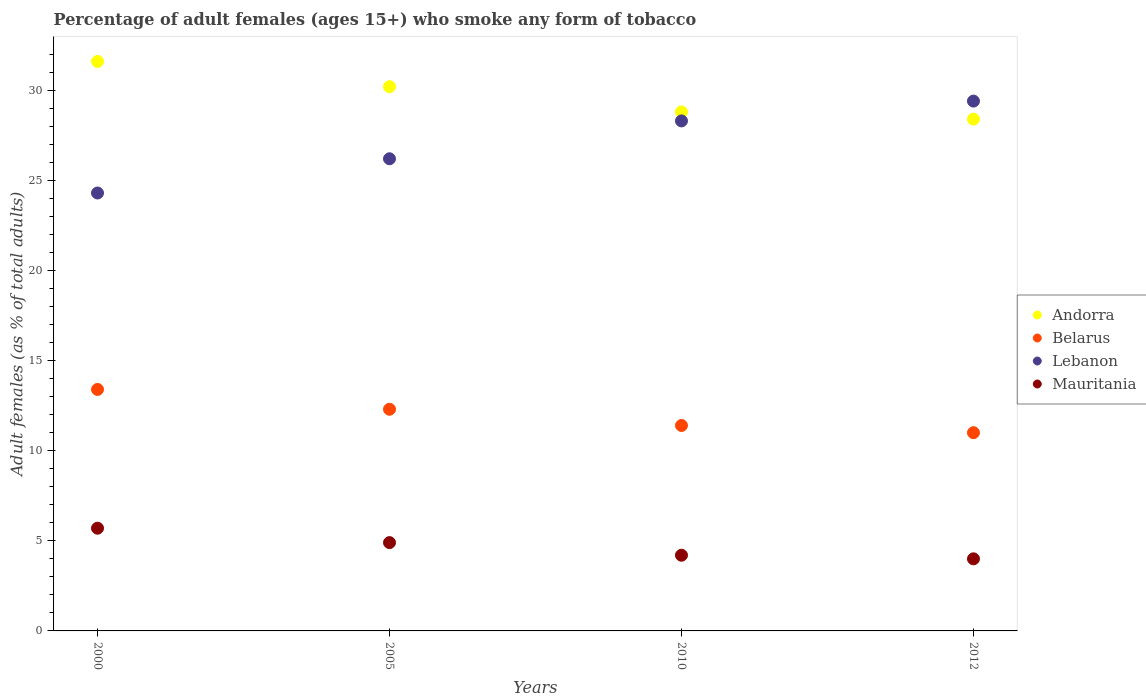How many different coloured dotlines are there?
Offer a terse response. 4. Is the number of dotlines equal to the number of legend labels?
Provide a succinct answer. Yes. What is the percentage of adult females who smoke in Mauritania in 2012?
Keep it short and to the point. 4. Across all years, what is the minimum percentage of adult females who smoke in Lebanon?
Your answer should be very brief. 24.3. What is the total percentage of adult females who smoke in Andorra in the graph?
Provide a short and direct response. 119. What is the average percentage of adult females who smoke in Lebanon per year?
Provide a short and direct response. 27.05. In the year 2012, what is the difference between the percentage of adult females who smoke in Mauritania and percentage of adult females who smoke in Andorra?
Your answer should be compact. -24.4. In how many years, is the percentage of adult females who smoke in Mauritania greater than 30 %?
Provide a succinct answer. 0. What is the ratio of the percentage of adult females who smoke in Andorra in 2000 to that in 2005?
Provide a succinct answer. 1.05. Is the percentage of adult females who smoke in Mauritania in 2000 less than that in 2005?
Your answer should be very brief. No. What is the difference between the highest and the second highest percentage of adult females who smoke in Belarus?
Offer a terse response. 1.1. What is the difference between the highest and the lowest percentage of adult females who smoke in Andorra?
Offer a very short reply. 3.2. Is the sum of the percentage of adult females who smoke in Lebanon in 2000 and 2012 greater than the maximum percentage of adult females who smoke in Andorra across all years?
Provide a short and direct response. Yes. Is the percentage of adult females who smoke in Andorra strictly greater than the percentage of adult females who smoke in Belarus over the years?
Your response must be concise. Yes. Is the percentage of adult females who smoke in Mauritania strictly less than the percentage of adult females who smoke in Belarus over the years?
Your response must be concise. Yes. How many dotlines are there?
Offer a very short reply. 4. How many years are there in the graph?
Offer a very short reply. 4. Are the values on the major ticks of Y-axis written in scientific E-notation?
Make the answer very short. No. Does the graph contain any zero values?
Provide a short and direct response. No. Does the graph contain grids?
Provide a short and direct response. No. How many legend labels are there?
Your answer should be compact. 4. What is the title of the graph?
Keep it short and to the point. Percentage of adult females (ages 15+) who smoke any form of tobacco. Does "St. Kitts and Nevis" appear as one of the legend labels in the graph?
Ensure brevity in your answer.  No. What is the label or title of the X-axis?
Keep it short and to the point. Years. What is the label or title of the Y-axis?
Keep it short and to the point. Adult females (as % of total adults). What is the Adult females (as % of total adults) in Andorra in 2000?
Provide a short and direct response. 31.6. What is the Adult females (as % of total adults) of Belarus in 2000?
Provide a succinct answer. 13.4. What is the Adult females (as % of total adults) of Lebanon in 2000?
Your answer should be very brief. 24.3. What is the Adult females (as % of total adults) in Mauritania in 2000?
Ensure brevity in your answer.  5.7. What is the Adult females (as % of total adults) in Andorra in 2005?
Make the answer very short. 30.2. What is the Adult females (as % of total adults) of Lebanon in 2005?
Provide a short and direct response. 26.2. What is the Adult females (as % of total adults) of Andorra in 2010?
Your response must be concise. 28.8. What is the Adult females (as % of total adults) of Belarus in 2010?
Your answer should be very brief. 11.4. What is the Adult females (as % of total adults) in Lebanon in 2010?
Provide a succinct answer. 28.3. What is the Adult females (as % of total adults) in Andorra in 2012?
Your answer should be compact. 28.4. What is the Adult females (as % of total adults) in Belarus in 2012?
Give a very brief answer. 11. What is the Adult females (as % of total adults) of Lebanon in 2012?
Make the answer very short. 29.4. Across all years, what is the maximum Adult females (as % of total adults) of Andorra?
Your answer should be compact. 31.6. Across all years, what is the maximum Adult females (as % of total adults) of Belarus?
Make the answer very short. 13.4. Across all years, what is the maximum Adult females (as % of total adults) in Lebanon?
Offer a terse response. 29.4. Across all years, what is the maximum Adult females (as % of total adults) in Mauritania?
Make the answer very short. 5.7. Across all years, what is the minimum Adult females (as % of total adults) of Andorra?
Your answer should be very brief. 28.4. Across all years, what is the minimum Adult females (as % of total adults) of Belarus?
Offer a very short reply. 11. Across all years, what is the minimum Adult females (as % of total adults) in Lebanon?
Your answer should be compact. 24.3. What is the total Adult females (as % of total adults) of Andorra in the graph?
Your answer should be very brief. 119. What is the total Adult females (as % of total adults) in Belarus in the graph?
Your answer should be compact. 48.1. What is the total Adult females (as % of total adults) of Lebanon in the graph?
Your response must be concise. 108.2. What is the difference between the Adult females (as % of total adults) of Mauritania in 2000 and that in 2005?
Ensure brevity in your answer.  0.8. What is the difference between the Adult females (as % of total adults) in Andorra in 2000 and that in 2012?
Provide a succinct answer. 3.2. What is the difference between the Adult females (as % of total adults) of Lebanon in 2000 and that in 2012?
Offer a terse response. -5.1. What is the difference between the Adult females (as % of total adults) in Mauritania in 2005 and that in 2010?
Offer a very short reply. 0.7. What is the difference between the Adult females (as % of total adults) of Andorra in 2005 and that in 2012?
Your response must be concise. 1.8. What is the difference between the Adult females (as % of total adults) in Mauritania in 2005 and that in 2012?
Provide a short and direct response. 0.9. What is the difference between the Adult females (as % of total adults) of Mauritania in 2010 and that in 2012?
Provide a short and direct response. 0.2. What is the difference between the Adult females (as % of total adults) of Andorra in 2000 and the Adult females (as % of total adults) of Belarus in 2005?
Keep it short and to the point. 19.3. What is the difference between the Adult females (as % of total adults) in Andorra in 2000 and the Adult females (as % of total adults) in Mauritania in 2005?
Your answer should be compact. 26.7. What is the difference between the Adult females (as % of total adults) of Lebanon in 2000 and the Adult females (as % of total adults) of Mauritania in 2005?
Offer a terse response. 19.4. What is the difference between the Adult females (as % of total adults) in Andorra in 2000 and the Adult females (as % of total adults) in Belarus in 2010?
Give a very brief answer. 20.2. What is the difference between the Adult females (as % of total adults) in Andorra in 2000 and the Adult females (as % of total adults) in Mauritania in 2010?
Your answer should be compact. 27.4. What is the difference between the Adult females (as % of total adults) of Belarus in 2000 and the Adult females (as % of total adults) of Lebanon in 2010?
Provide a succinct answer. -14.9. What is the difference between the Adult females (as % of total adults) in Lebanon in 2000 and the Adult females (as % of total adults) in Mauritania in 2010?
Ensure brevity in your answer.  20.1. What is the difference between the Adult females (as % of total adults) of Andorra in 2000 and the Adult females (as % of total adults) of Belarus in 2012?
Make the answer very short. 20.6. What is the difference between the Adult females (as % of total adults) in Andorra in 2000 and the Adult females (as % of total adults) in Lebanon in 2012?
Keep it short and to the point. 2.2. What is the difference between the Adult females (as % of total adults) of Andorra in 2000 and the Adult females (as % of total adults) of Mauritania in 2012?
Provide a succinct answer. 27.6. What is the difference between the Adult females (as % of total adults) of Belarus in 2000 and the Adult females (as % of total adults) of Lebanon in 2012?
Your response must be concise. -16. What is the difference between the Adult females (as % of total adults) in Belarus in 2000 and the Adult females (as % of total adults) in Mauritania in 2012?
Ensure brevity in your answer.  9.4. What is the difference between the Adult females (as % of total adults) of Lebanon in 2000 and the Adult females (as % of total adults) of Mauritania in 2012?
Make the answer very short. 20.3. What is the difference between the Adult females (as % of total adults) in Andorra in 2005 and the Adult females (as % of total adults) in Belarus in 2010?
Give a very brief answer. 18.8. What is the difference between the Adult females (as % of total adults) of Andorra in 2005 and the Adult females (as % of total adults) of Mauritania in 2010?
Give a very brief answer. 26. What is the difference between the Adult females (as % of total adults) of Lebanon in 2005 and the Adult females (as % of total adults) of Mauritania in 2010?
Keep it short and to the point. 22. What is the difference between the Adult females (as % of total adults) of Andorra in 2005 and the Adult females (as % of total adults) of Belarus in 2012?
Provide a short and direct response. 19.2. What is the difference between the Adult females (as % of total adults) of Andorra in 2005 and the Adult females (as % of total adults) of Lebanon in 2012?
Provide a short and direct response. 0.8. What is the difference between the Adult females (as % of total adults) in Andorra in 2005 and the Adult females (as % of total adults) in Mauritania in 2012?
Your response must be concise. 26.2. What is the difference between the Adult females (as % of total adults) of Belarus in 2005 and the Adult females (as % of total adults) of Lebanon in 2012?
Provide a short and direct response. -17.1. What is the difference between the Adult females (as % of total adults) of Belarus in 2005 and the Adult females (as % of total adults) of Mauritania in 2012?
Your answer should be compact. 8.3. What is the difference between the Adult females (as % of total adults) in Andorra in 2010 and the Adult females (as % of total adults) in Belarus in 2012?
Make the answer very short. 17.8. What is the difference between the Adult females (as % of total adults) in Andorra in 2010 and the Adult females (as % of total adults) in Lebanon in 2012?
Ensure brevity in your answer.  -0.6. What is the difference between the Adult females (as % of total adults) of Andorra in 2010 and the Adult females (as % of total adults) of Mauritania in 2012?
Your answer should be compact. 24.8. What is the difference between the Adult females (as % of total adults) of Belarus in 2010 and the Adult females (as % of total adults) of Lebanon in 2012?
Give a very brief answer. -18. What is the difference between the Adult females (as % of total adults) in Lebanon in 2010 and the Adult females (as % of total adults) in Mauritania in 2012?
Your answer should be compact. 24.3. What is the average Adult females (as % of total adults) in Andorra per year?
Ensure brevity in your answer.  29.75. What is the average Adult females (as % of total adults) in Belarus per year?
Keep it short and to the point. 12.03. What is the average Adult females (as % of total adults) in Lebanon per year?
Make the answer very short. 27.05. What is the average Adult females (as % of total adults) in Mauritania per year?
Offer a terse response. 4.7. In the year 2000, what is the difference between the Adult females (as % of total adults) in Andorra and Adult females (as % of total adults) in Lebanon?
Ensure brevity in your answer.  7.3. In the year 2000, what is the difference between the Adult females (as % of total adults) of Andorra and Adult females (as % of total adults) of Mauritania?
Offer a terse response. 25.9. In the year 2000, what is the difference between the Adult females (as % of total adults) in Belarus and Adult females (as % of total adults) in Lebanon?
Provide a short and direct response. -10.9. In the year 2000, what is the difference between the Adult females (as % of total adults) of Belarus and Adult females (as % of total adults) of Mauritania?
Keep it short and to the point. 7.7. In the year 2000, what is the difference between the Adult females (as % of total adults) in Lebanon and Adult females (as % of total adults) in Mauritania?
Give a very brief answer. 18.6. In the year 2005, what is the difference between the Adult females (as % of total adults) of Andorra and Adult females (as % of total adults) of Lebanon?
Provide a short and direct response. 4. In the year 2005, what is the difference between the Adult females (as % of total adults) in Andorra and Adult females (as % of total adults) in Mauritania?
Offer a terse response. 25.3. In the year 2005, what is the difference between the Adult females (as % of total adults) in Belarus and Adult females (as % of total adults) in Lebanon?
Make the answer very short. -13.9. In the year 2005, what is the difference between the Adult females (as % of total adults) of Belarus and Adult females (as % of total adults) of Mauritania?
Ensure brevity in your answer.  7.4. In the year 2005, what is the difference between the Adult females (as % of total adults) of Lebanon and Adult females (as % of total adults) of Mauritania?
Offer a very short reply. 21.3. In the year 2010, what is the difference between the Adult females (as % of total adults) of Andorra and Adult females (as % of total adults) of Mauritania?
Ensure brevity in your answer.  24.6. In the year 2010, what is the difference between the Adult females (as % of total adults) in Belarus and Adult females (as % of total adults) in Lebanon?
Provide a succinct answer. -16.9. In the year 2010, what is the difference between the Adult females (as % of total adults) in Belarus and Adult females (as % of total adults) in Mauritania?
Provide a short and direct response. 7.2. In the year 2010, what is the difference between the Adult females (as % of total adults) in Lebanon and Adult females (as % of total adults) in Mauritania?
Give a very brief answer. 24.1. In the year 2012, what is the difference between the Adult females (as % of total adults) in Andorra and Adult females (as % of total adults) in Belarus?
Give a very brief answer. 17.4. In the year 2012, what is the difference between the Adult females (as % of total adults) in Andorra and Adult females (as % of total adults) in Mauritania?
Your response must be concise. 24.4. In the year 2012, what is the difference between the Adult females (as % of total adults) of Belarus and Adult females (as % of total adults) of Lebanon?
Make the answer very short. -18.4. In the year 2012, what is the difference between the Adult females (as % of total adults) of Lebanon and Adult females (as % of total adults) of Mauritania?
Give a very brief answer. 25.4. What is the ratio of the Adult females (as % of total adults) of Andorra in 2000 to that in 2005?
Your response must be concise. 1.05. What is the ratio of the Adult females (as % of total adults) of Belarus in 2000 to that in 2005?
Your answer should be compact. 1.09. What is the ratio of the Adult females (as % of total adults) in Lebanon in 2000 to that in 2005?
Give a very brief answer. 0.93. What is the ratio of the Adult females (as % of total adults) in Mauritania in 2000 to that in 2005?
Offer a terse response. 1.16. What is the ratio of the Adult females (as % of total adults) of Andorra in 2000 to that in 2010?
Make the answer very short. 1.1. What is the ratio of the Adult females (as % of total adults) in Belarus in 2000 to that in 2010?
Keep it short and to the point. 1.18. What is the ratio of the Adult females (as % of total adults) of Lebanon in 2000 to that in 2010?
Make the answer very short. 0.86. What is the ratio of the Adult females (as % of total adults) of Mauritania in 2000 to that in 2010?
Your answer should be very brief. 1.36. What is the ratio of the Adult females (as % of total adults) of Andorra in 2000 to that in 2012?
Make the answer very short. 1.11. What is the ratio of the Adult females (as % of total adults) of Belarus in 2000 to that in 2012?
Your response must be concise. 1.22. What is the ratio of the Adult females (as % of total adults) in Lebanon in 2000 to that in 2012?
Offer a very short reply. 0.83. What is the ratio of the Adult females (as % of total adults) of Mauritania in 2000 to that in 2012?
Your answer should be compact. 1.43. What is the ratio of the Adult females (as % of total adults) of Andorra in 2005 to that in 2010?
Your answer should be compact. 1.05. What is the ratio of the Adult females (as % of total adults) of Belarus in 2005 to that in 2010?
Your answer should be very brief. 1.08. What is the ratio of the Adult females (as % of total adults) of Lebanon in 2005 to that in 2010?
Provide a succinct answer. 0.93. What is the ratio of the Adult females (as % of total adults) in Mauritania in 2005 to that in 2010?
Make the answer very short. 1.17. What is the ratio of the Adult females (as % of total adults) in Andorra in 2005 to that in 2012?
Make the answer very short. 1.06. What is the ratio of the Adult females (as % of total adults) of Belarus in 2005 to that in 2012?
Your answer should be compact. 1.12. What is the ratio of the Adult females (as % of total adults) in Lebanon in 2005 to that in 2012?
Provide a succinct answer. 0.89. What is the ratio of the Adult females (as % of total adults) in Mauritania in 2005 to that in 2012?
Provide a succinct answer. 1.23. What is the ratio of the Adult females (as % of total adults) in Andorra in 2010 to that in 2012?
Your response must be concise. 1.01. What is the ratio of the Adult females (as % of total adults) of Belarus in 2010 to that in 2012?
Your answer should be very brief. 1.04. What is the ratio of the Adult females (as % of total adults) in Lebanon in 2010 to that in 2012?
Your response must be concise. 0.96. What is the ratio of the Adult females (as % of total adults) in Mauritania in 2010 to that in 2012?
Offer a terse response. 1.05. What is the difference between the highest and the second highest Adult females (as % of total adults) in Belarus?
Keep it short and to the point. 1.1. What is the difference between the highest and the second highest Adult females (as % of total adults) in Lebanon?
Give a very brief answer. 1.1. What is the difference between the highest and the lowest Adult females (as % of total adults) of Belarus?
Make the answer very short. 2.4. What is the difference between the highest and the lowest Adult females (as % of total adults) in Lebanon?
Your answer should be compact. 5.1. 